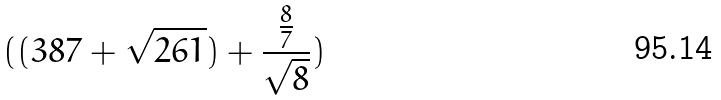Convert formula to latex. <formula><loc_0><loc_0><loc_500><loc_500>( ( 3 8 7 + \sqrt { 2 6 1 } ) + \frac { \frac { 8 } { 7 } } { \sqrt { 8 } } )</formula> 